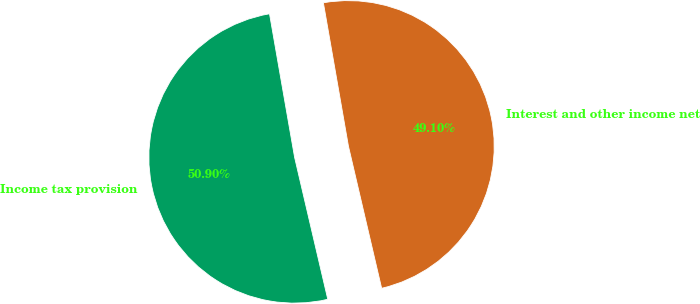Convert chart. <chart><loc_0><loc_0><loc_500><loc_500><pie_chart><fcel>Interest and other income net<fcel>Income tax provision<nl><fcel>49.1%<fcel>50.9%<nl></chart> 